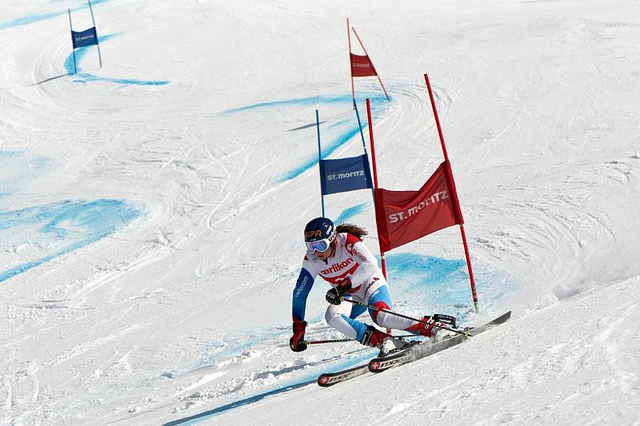<image>Is the snow fresh? It is ambiguous if the snow is fresh. Is the snow fresh? I don't know if the snow is fresh. It can be either fresh or not fresh. 